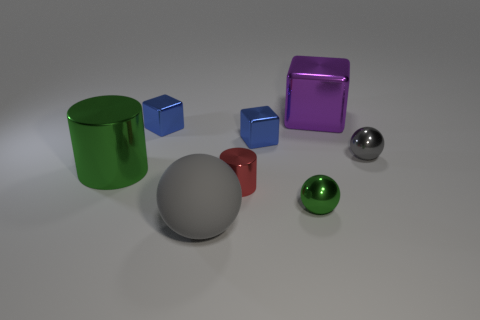What shape is the blue metal thing on the left side of the tiny metal cube that is right of the small blue metallic object that is on the left side of the large rubber thing?
Make the answer very short. Cube. Does the tiny cube that is right of the large gray sphere have the same color as the metallic object on the right side of the purple metallic thing?
Make the answer very short. No. What number of big yellow things are there?
Keep it short and to the point. 0. There is a matte ball; are there any large gray spheres behind it?
Offer a very short reply. No. Do the green thing that is left of the small green sphere and the blue object that is left of the small metal cylinder have the same material?
Provide a succinct answer. Yes. Are there fewer large gray spheres that are to the left of the matte sphere than big purple things?
Your answer should be very brief. Yes. There is a cylinder that is to the left of the gray rubber thing; what is its color?
Your answer should be very brief. Green. The tiny sphere that is to the left of the shiny thing that is on the right side of the purple thing is made of what material?
Your answer should be very brief. Metal. Is there a green sphere of the same size as the green cylinder?
Make the answer very short. No. What number of things are large shiny objects that are on the left side of the big matte thing or large shiny things behind the large green thing?
Make the answer very short. 2. 